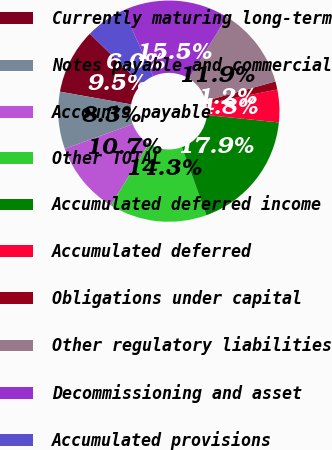Convert chart to OTSL. <chart><loc_0><loc_0><loc_500><loc_500><pie_chart><fcel>Currently maturing long-term<fcel>Notes payable and commercial<fcel>Accounts payable<fcel>Other TOTAL<fcel>Accumulated deferred income<fcel>Accumulated deferred<fcel>Obligations under capital<fcel>Other regulatory liabilities<fcel>Decommissioning and asset<fcel>Accumulated provisions<nl><fcel>9.52%<fcel>8.33%<fcel>10.71%<fcel>14.29%<fcel>17.86%<fcel>4.76%<fcel>1.19%<fcel>11.9%<fcel>15.48%<fcel>5.95%<nl></chart> 